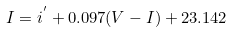<formula> <loc_0><loc_0><loc_500><loc_500>I = i ^ { ^ { \prime } } + 0 . 0 9 7 ( V - I ) + 2 3 . 1 4 2</formula> 